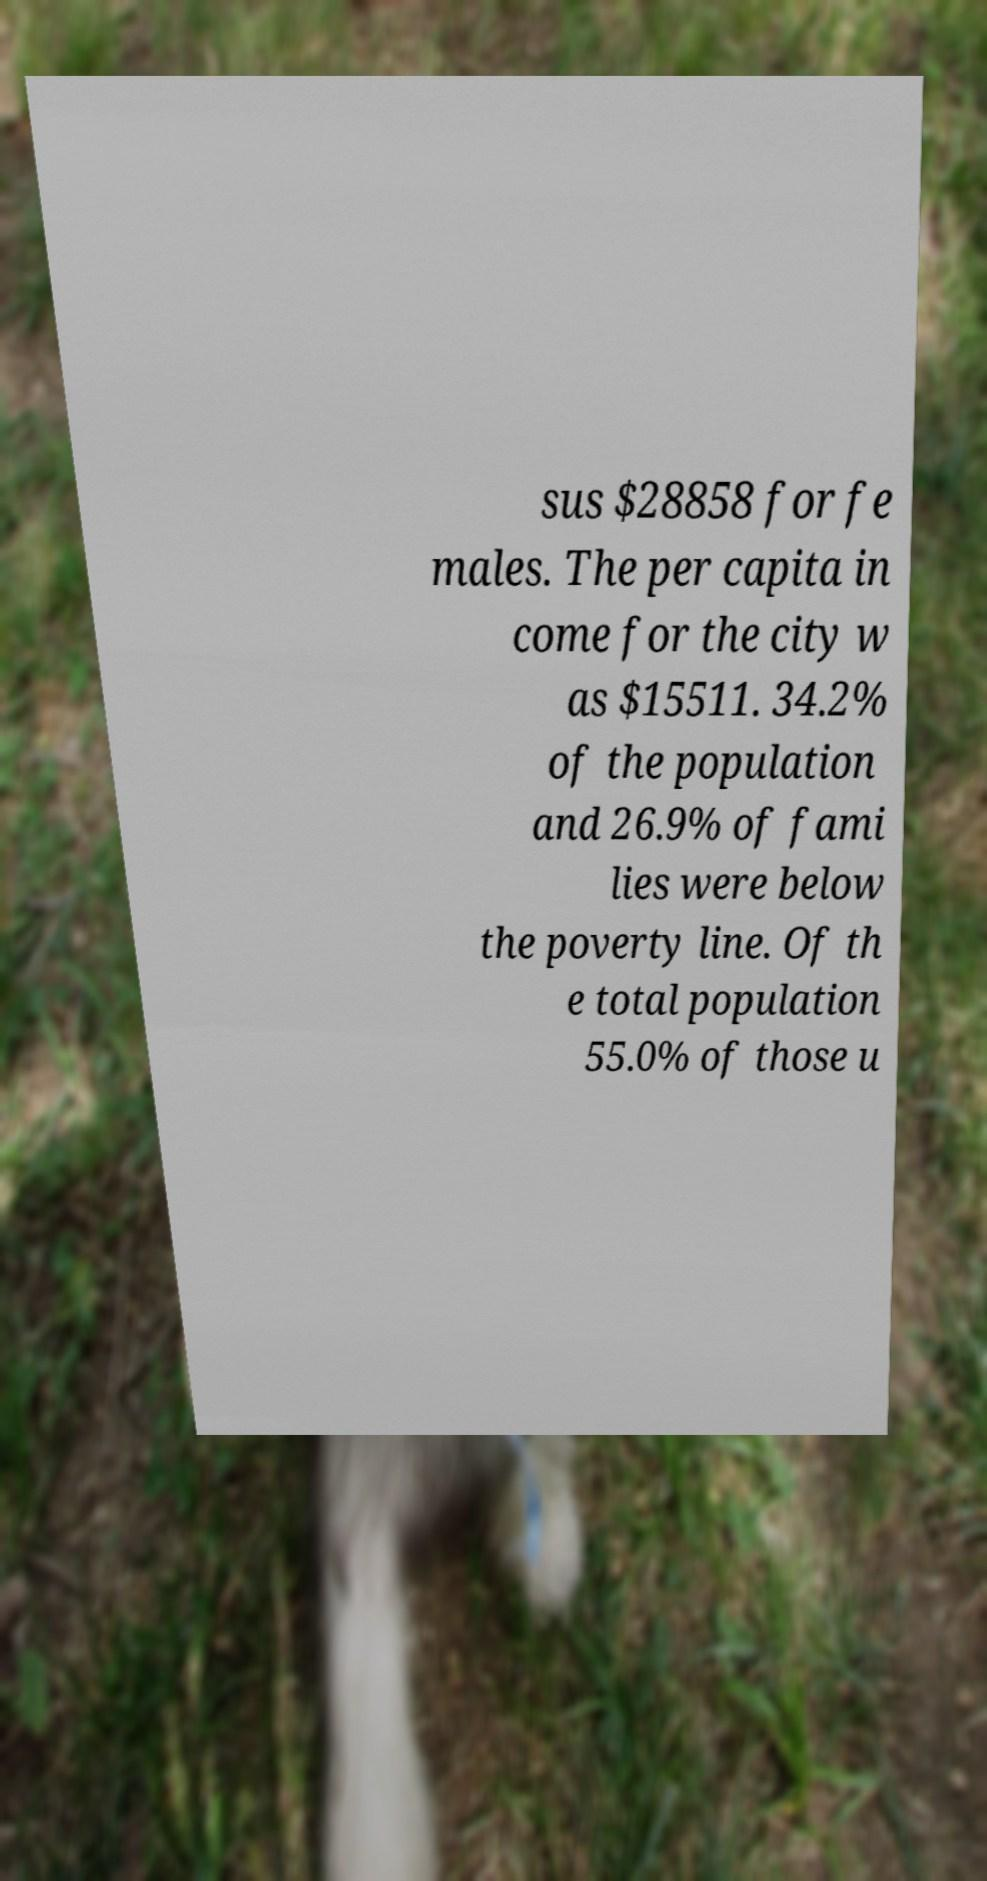Please read and relay the text visible in this image. What does it say? sus $28858 for fe males. The per capita in come for the city w as $15511. 34.2% of the population and 26.9% of fami lies were below the poverty line. Of th e total population 55.0% of those u 